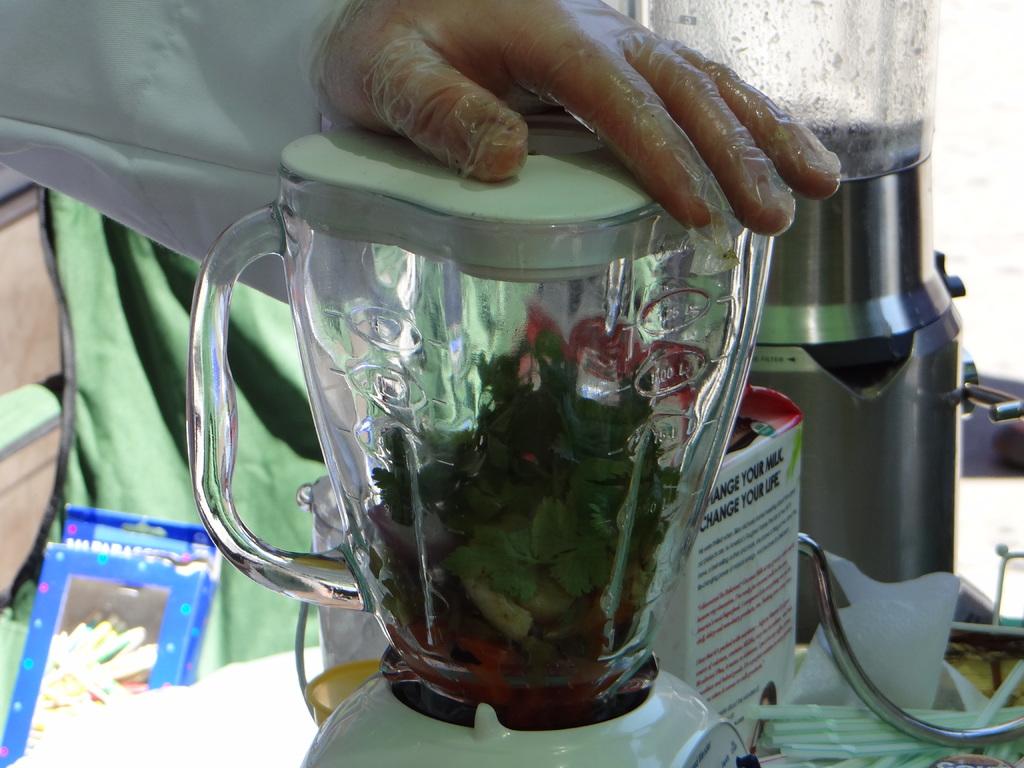On the carton what do you change?
Your response must be concise. Your life. 